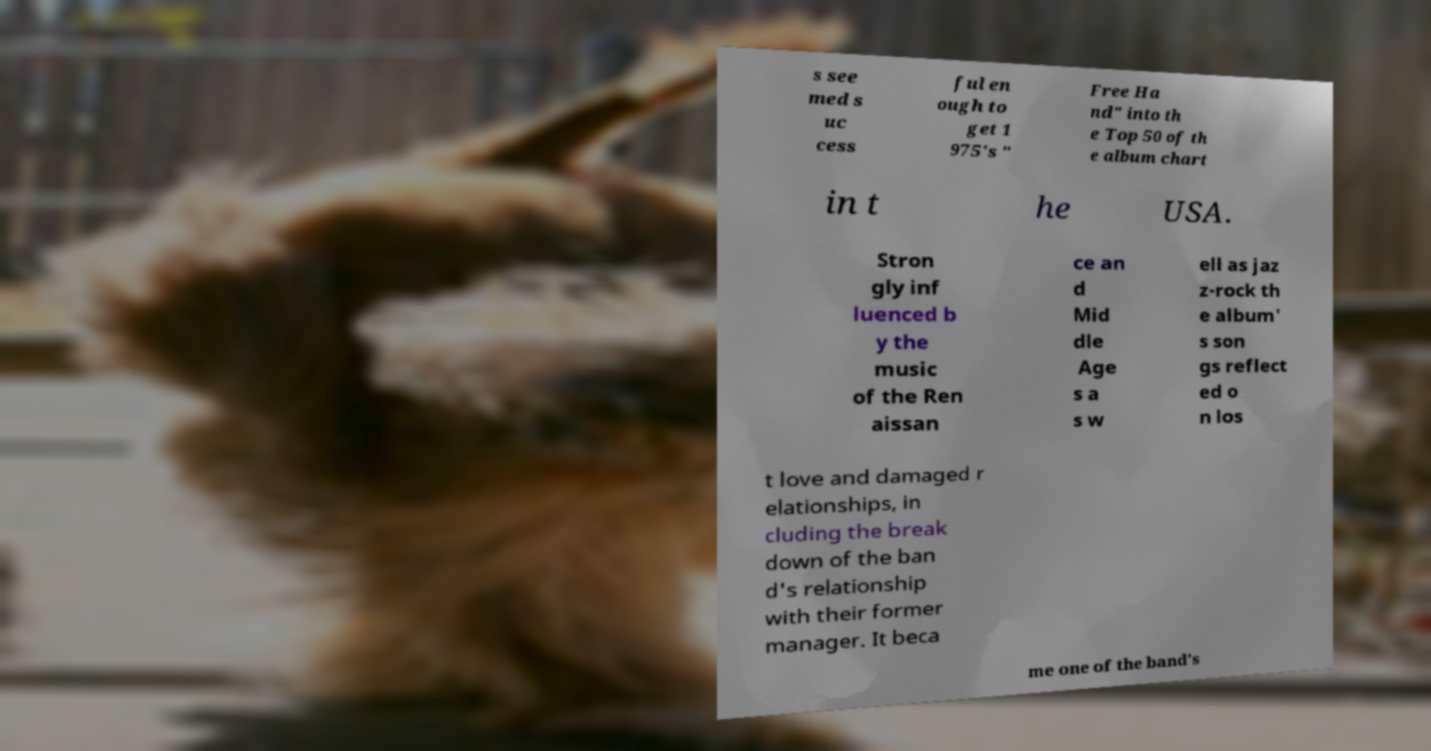Please read and relay the text visible in this image. What does it say? s see med s uc cess ful en ough to get 1 975's " Free Ha nd" into th e Top 50 of th e album chart in t he USA. Stron gly inf luenced b y the music of the Ren aissan ce an d Mid dle Age s a s w ell as jaz z-rock th e album' s son gs reflect ed o n los t love and damaged r elationships, in cluding the break down of the ban d's relationship with their former manager. It beca me one of the band's 